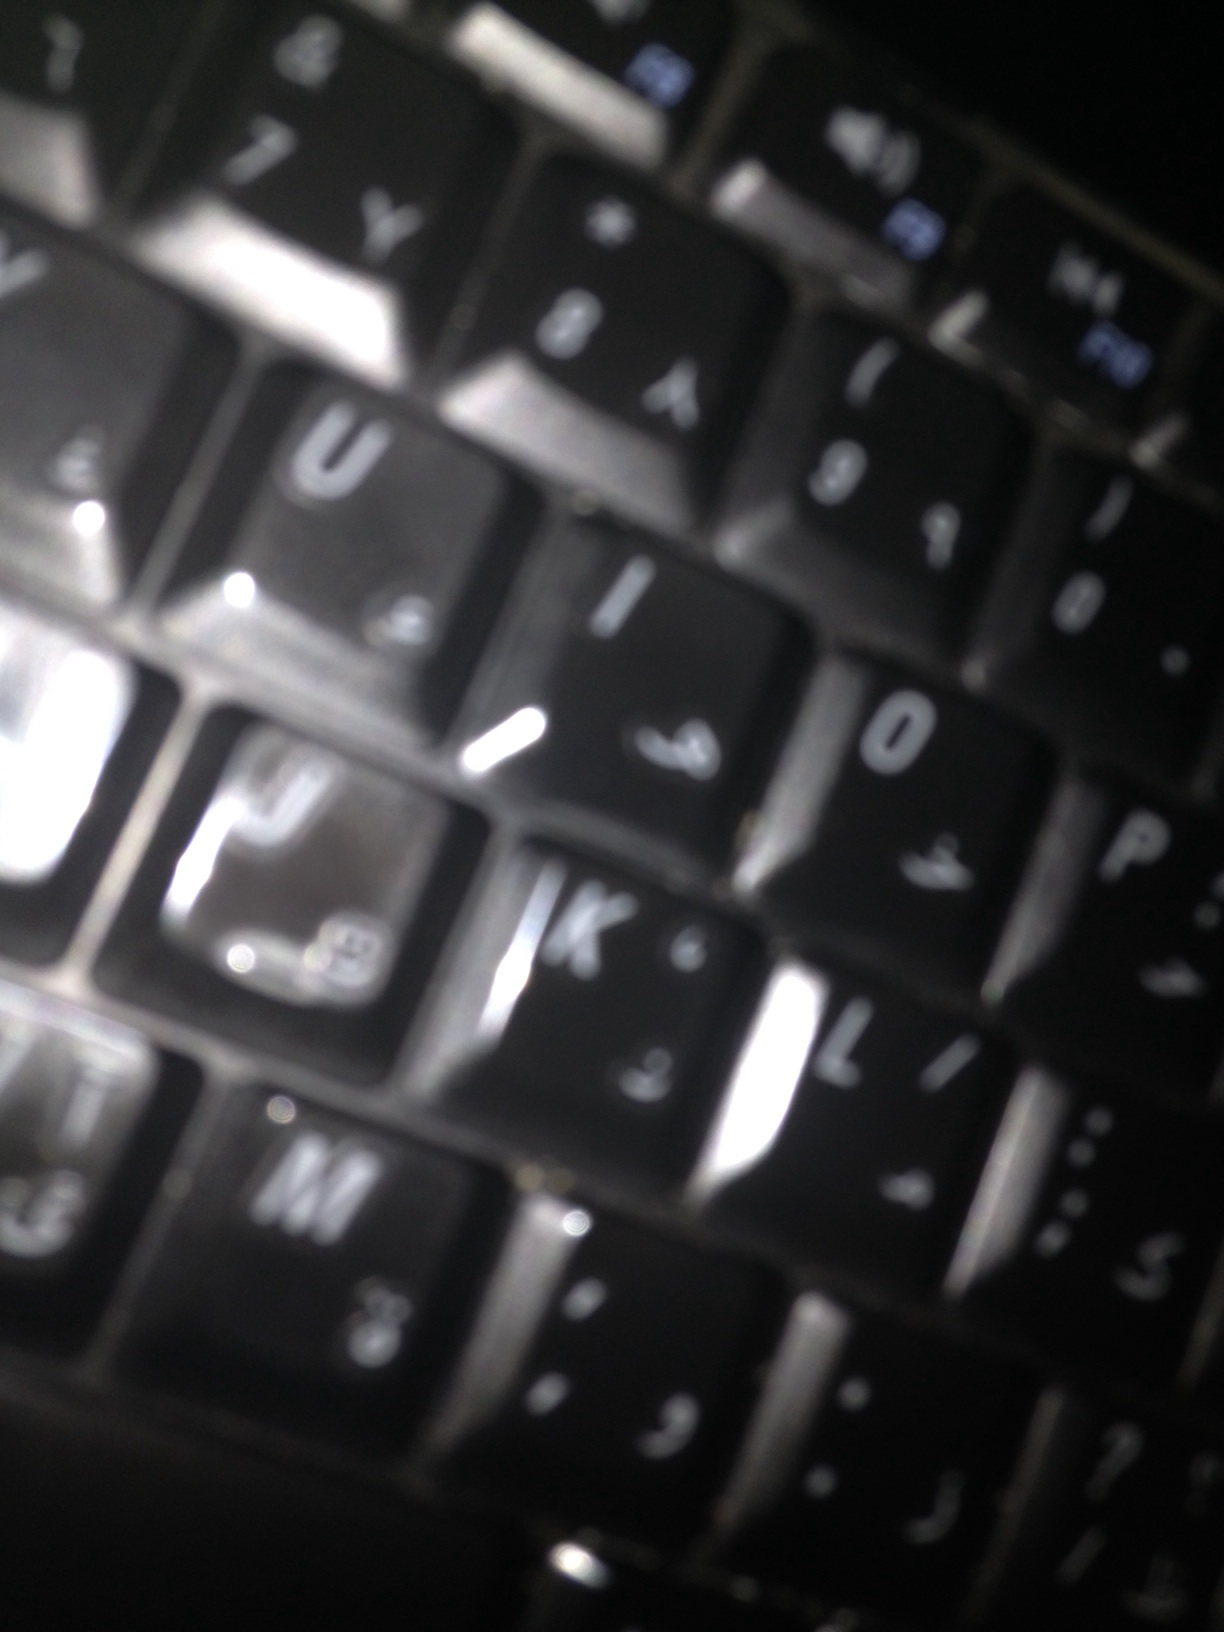Can you describe the scene where this keyboard might be found? This keyboard could be found on a desk in an office or a home workspace. The environment is likely to be one where computers and digital devices are used frequently. Imagine if this keyboard could talk. What story would it tell? If this keyboard could talk, it might tell the story of countless hours of work and communication. Each key press might represent a message sent to a distant friend, a report painstakingly crafted, or perhaps the creative outpouring of a novel being written. It has witnessed moments of frustration, joy, and relentless typing into the late hours of the night. What could be an extremely detailed description of the keyboard's features? This keyboard is a standard QWERTY model with what appears to be an Arabic dual layout. The keys are black with white lettering, showing slight signs of wear on some of the most frequently used keys, like the 'E', 'R', 'T', and 'I'. The surface is glossy, reflecting light in a way that emphasizes the contours of the keys. Some faint smudges might suggest it has been used without a recent cleaning. The keycaps are slightly concave, designed to fit the fingertips comfortably. The symbols and letters are crisply printed, ensuring clarity. The layout is likely ergonomic, allowing for efficient typing. The presence of both languages on the keys suggests it was manufactured for a bilingual user. 